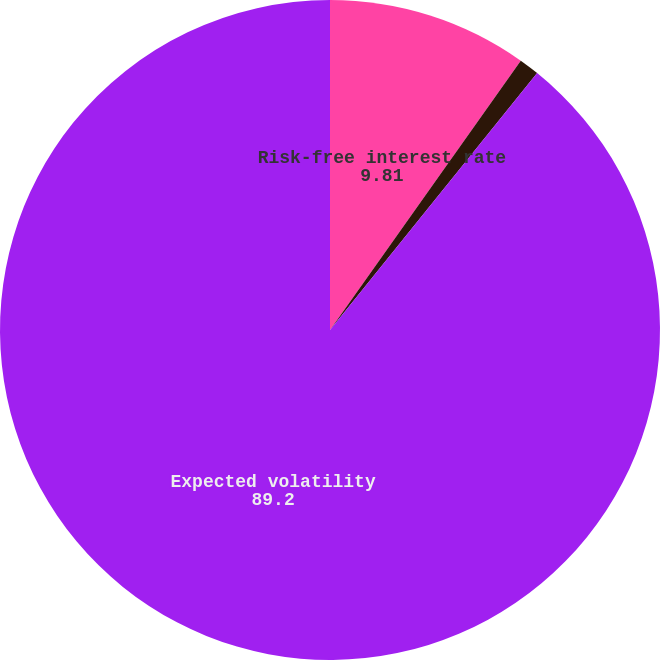<chart> <loc_0><loc_0><loc_500><loc_500><pie_chart><fcel>Risk-free interest rate<fcel>Expected life (years)<fcel>Expected volatility<nl><fcel>9.81%<fcel>0.99%<fcel>89.2%<nl></chart> 